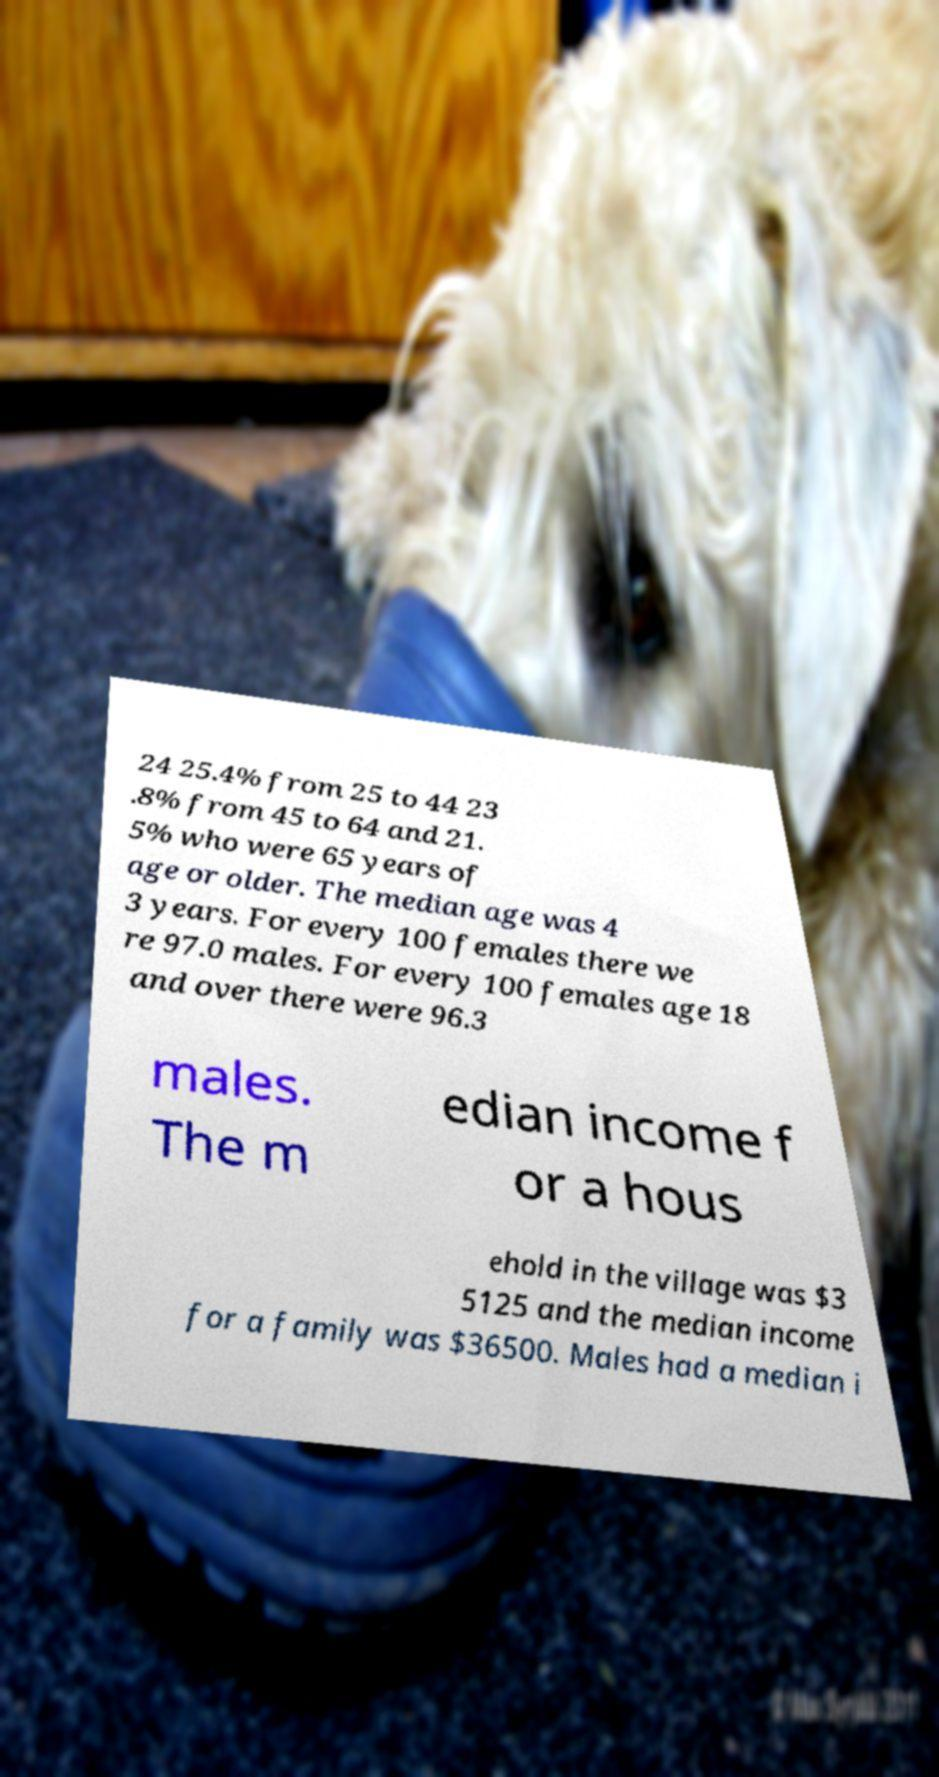Please read and relay the text visible in this image. What does it say? 24 25.4% from 25 to 44 23 .8% from 45 to 64 and 21. 5% who were 65 years of age or older. The median age was 4 3 years. For every 100 females there we re 97.0 males. For every 100 females age 18 and over there were 96.3 males. The m edian income f or a hous ehold in the village was $3 5125 and the median income for a family was $36500. Males had a median i 